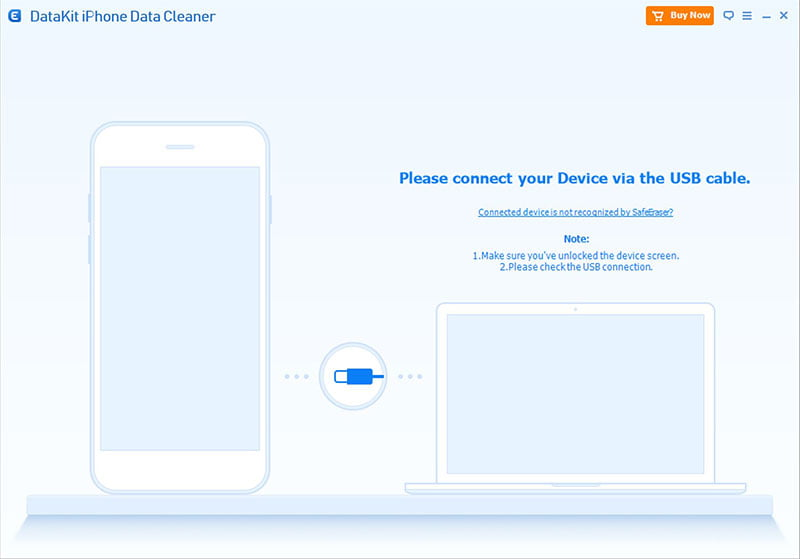Can you explain why unlocking the device might be a necessary step for establishing a USB connection? Unlocking the device is a necessary step for establishing a USB connection because many devices have security measures that prevent data access while the screen is locked. This is to protect the user's information and ensure that data transfers are intentional. When the device is locked, the USB connection may be limited to charging or other restricted functions. By unlocking the device screen, you are granting permission for data access and transfer to the connected computer. What should I do if the USB connection still fails after following these tips? If the USB connection still fails after ensuring the device screen is unlocked and the USB cable is correctly connected, you can try the following steps:
1. Restart both your device and your computer.
2. Verify that you are using a compatible USB cable and port.
3. Check the device's settings to ensure USB debugging is enabled (especially for Android devices).
4. Update or reinstall the device drivers on your computer.
5. Try connecting to a different USB port on the computer.
6. Test the connection with a different USB cable to rule out a faulty cable.
7. Ensure that the device is not in power-saving mode, which could affect its connectivity.
If all else fails, referring to the device's user manual or seeking technical support may provide additional solutions. Is there any way to wirelessly connect the device to the software instead of using a USB cable? Some software applications offer wireless connectivity options, such as Wi-Fi or Bluetooth, for data transfer and communication between a device and a computer. To check if this is available for your software:
1. Navigate through the software's settings or connection options to look for wireless connection alternatives.
2. Ensure both your device and computer are connected to the sharegpt4v/same Wi-Fi network if using a Wi-Fi connection.
3. Enable Bluetooth on both your device and computer, and pair them for Bluetooth-based connections.
4. Follow any additional instructions provided by the software to configure and establish a wireless connection.
While USB connections are generally more reliable and faster, wireless options can provide a convenient alternative if supported by the software. 